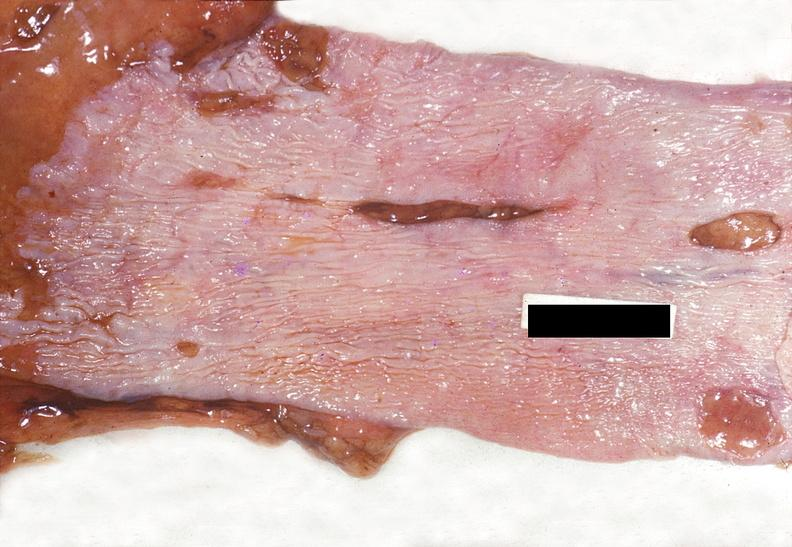s band constriction in skin above ankle of infant present?
Answer the question using a single word or phrase. No 